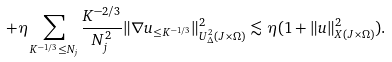Convert formula to latex. <formula><loc_0><loc_0><loc_500><loc_500>+ \eta \sum _ { K ^ { - 1 / 3 } \leq N _ { j } } \frac { K ^ { - 2 / 3 } } { N _ { j } ^ { 2 } } \| \nabla u _ { \leq K ^ { - 1 / 3 } } \| _ { U _ { \Delta } ^ { 2 } ( J \times \Omega ) } ^ { 2 } \lesssim \eta ( 1 + \| u \| _ { X ( J \times \Omega ) } ^ { 2 } ) .</formula> 